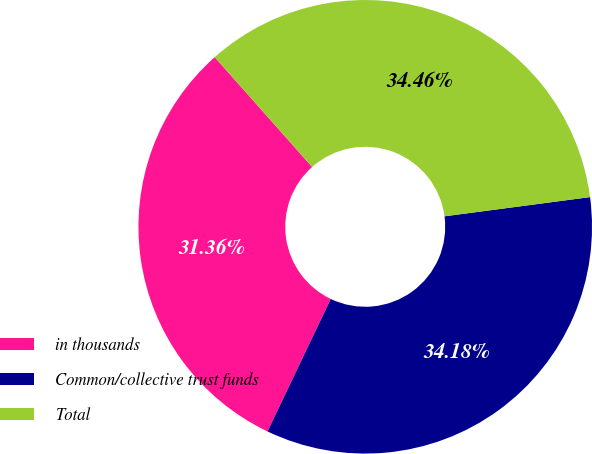Convert chart to OTSL. <chart><loc_0><loc_0><loc_500><loc_500><pie_chart><fcel>in thousands<fcel>Common/collective trust funds<fcel>Total<nl><fcel>31.36%<fcel>34.18%<fcel>34.46%<nl></chart> 